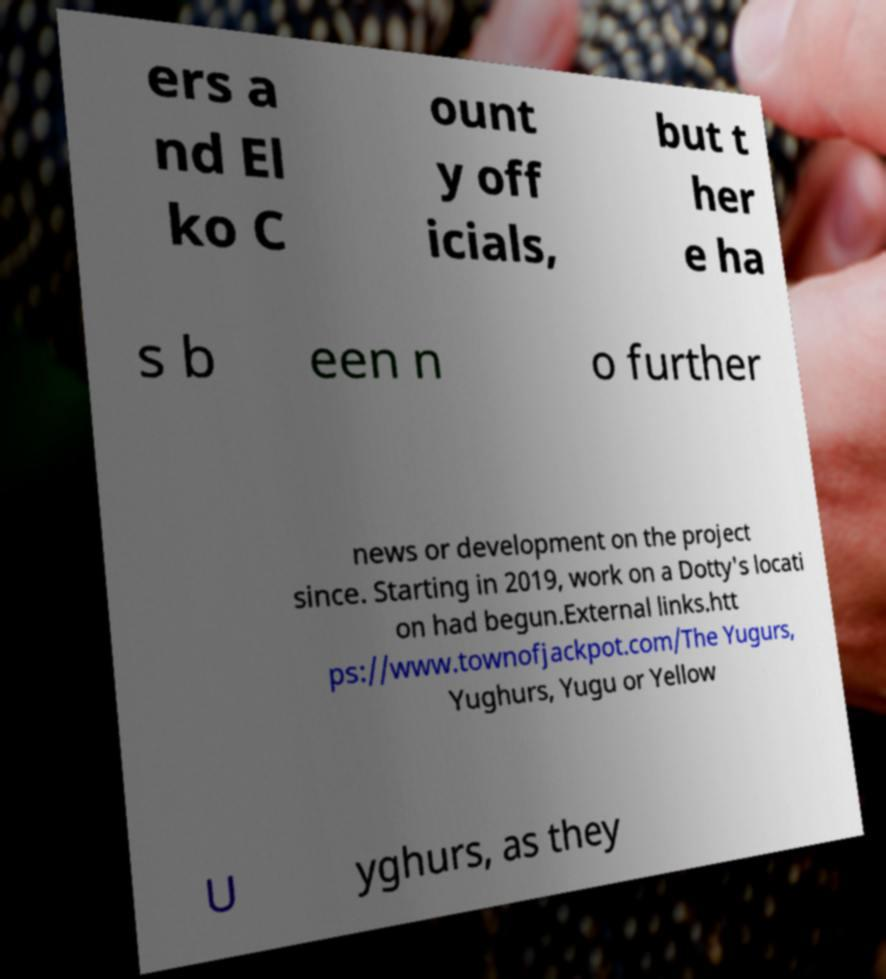Could you assist in decoding the text presented in this image and type it out clearly? ers a nd El ko C ount y off icials, but t her e ha s b een n o further news or development on the project since. Starting in 2019, work on a Dotty's locati on had begun.External links.htt ps://www.townofjackpot.com/The Yugurs, Yughurs, Yugu or Yellow U yghurs, as they 